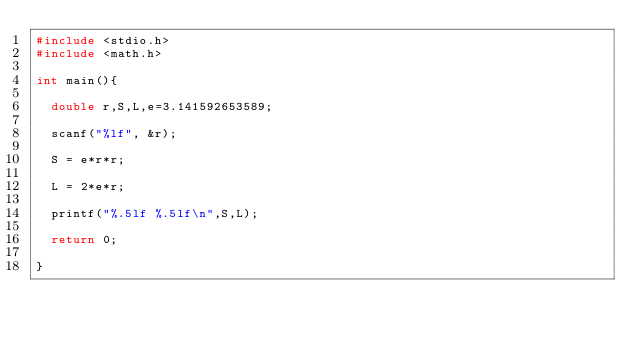Convert code to text. <code><loc_0><loc_0><loc_500><loc_500><_C_>#include <stdio.h>
#include <math.h>

int main(){

  double r,S,L,e=3.141592653589;

  scanf("%lf", &r);

  S = e*r*r;

  L = 2*e*r;

  printf("%.5lf %.5lf\n",S,L);

  return 0;

}</code> 